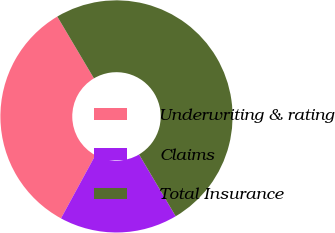Convert chart. <chart><loc_0><loc_0><loc_500><loc_500><pie_chart><fcel>Underwriting & rating<fcel>Claims<fcel>Total Insurance<nl><fcel>33.55%<fcel>16.45%<fcel>50.0%<nl></chart> 